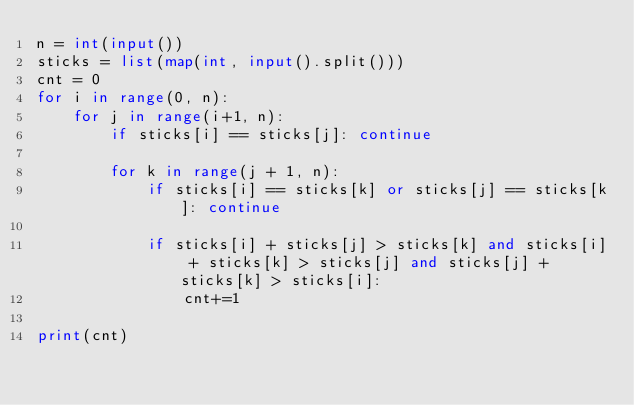<code> <loc_0><loc_0><loc_500><loc_500><_Python_>n = int(input())
sticks = list(map(int, input().split()))
cnt = 0
for i in range(0, n):
    for j in range(i+1, n):
        if sticks[i] == sticks[j]: continue

        for k in range(j + 1, n):
            if sticks[i] == sticks[k] or sticks[j] == sticks[k]: continue
            
            if sticks[i] + sticks[j] > sticks[k] and sticks[i] + sticks[k] > sticks[j] and sticks[j] + sticks[k] > sticks[i]:
                cnt+=1

print(cnt)</code> 